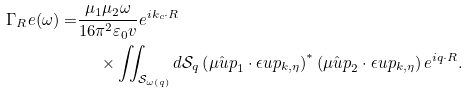<formula> <loc_0><loc_0><loc_500><loc_500>\Gamma _ { R } e ( \omega ) = & \frac { \mu _ { 1 } \mu _ { 2 } \omega } { 1 6 \pi ^ { 2 } \varepsilon _ { 0 } v } e ^ { i k _ { c } \cdot R } \\ & \quad \ \times \iint _ { \mathcal { S } _ { \omega \left ( q \right ) } } d \mathcal { S } _ { q } \left ( \hat { \mu u p } _ { 1 } \cdot \epsilon u p _ { k , \eta } \right ) ^ { \ast } \left ( \hat { \mu u p } _ { 2 } \cdot \epsilon u p _ { k , \eta } \right ) e ^ { i q \cdot R } .</formula> 